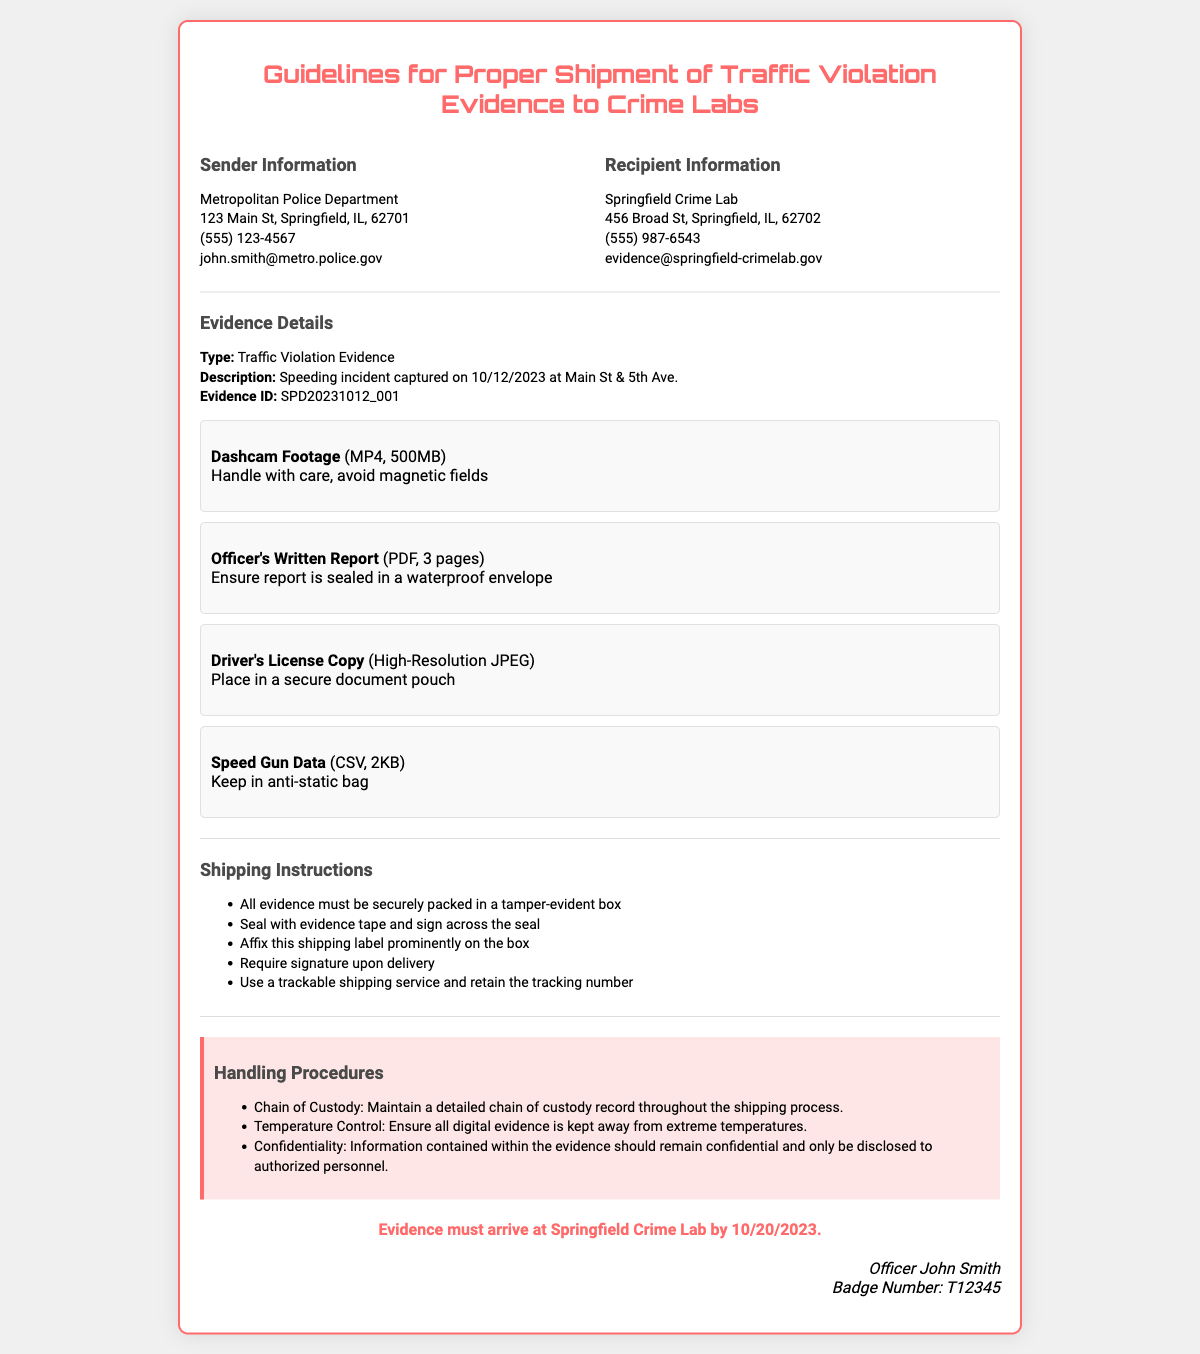What is the sender's email address? The sender's email address is located in the Sender Information section.
Answer: john.smith@metro.police.gov What is the evidence ID? The evidence ID is specified in the Evidence Details section.
Answer: SPD20231012_001 What type of evidence is listed? The type of evidence is mentioned in the Evidence Details section.
Answer: Traffic Violation Evidence What must be used for sealing the box? The Shipping Instructions section points out how to secure the evidence package.
Answer: Evidence tape What is the due date for the evidence arrival? The due date is stated clearly at the end of the document.
Answer: 10/20/2023 How should the Officer's Written Report be packed? The packing requirement for the report is mentioned in the Evidence Details section.
Answer: Sealed in a waterproof envelope What is the recipient's phone number? The recipient's phone number is found in the Recipient Information section.
Answer: (555) 987-6543 What are the handling procedures for confidentiality? The handling procedures specify how to manage the evidence's confidentiality.
Answer: Remain confidential How many pages is the Officer's Written Report? The number of pages is provided in the Evidence Details section.
Answer: 3 pages 